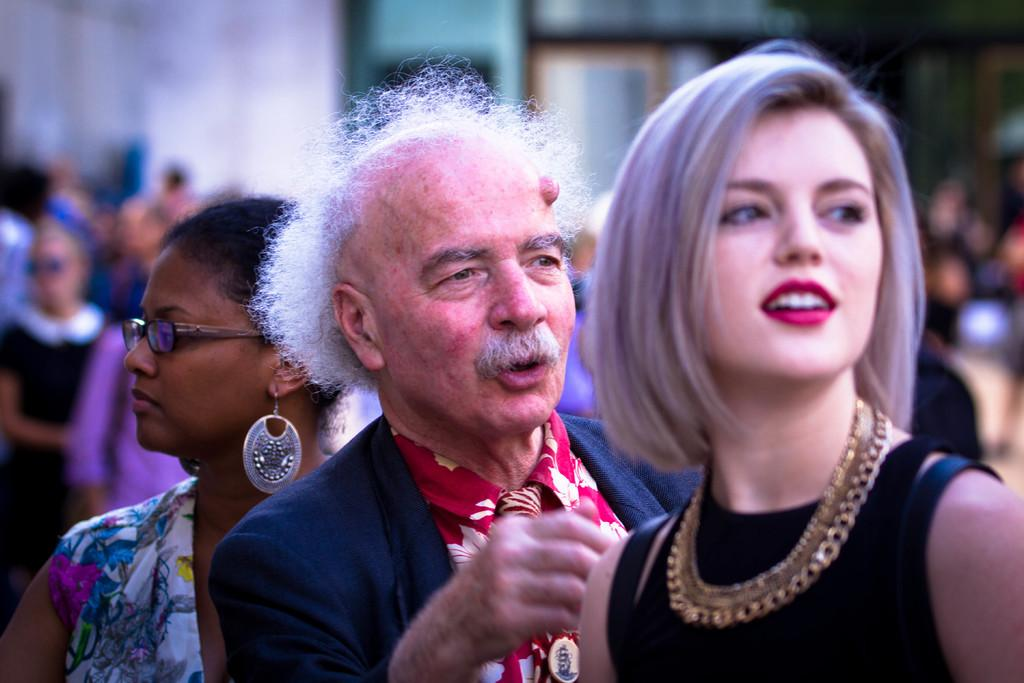Who or what is present in the image? There are people in the image. What are the people wearing? The people are wearing different color dresses. Can you describe the background of the image? The background of the image is blurred. How many robins can be seen in the image? There are no robins present in the image; it features people wearing different color dresses. What type of lizards are crawling on the floor in the image? There are no lizards present in the image. 